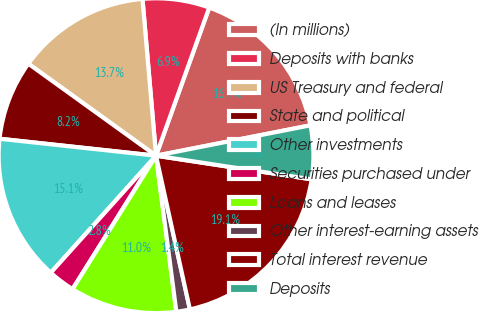<chart> <loc_0><loc_0><loc_500><loc_500><pie_chart><fcel>(In millions)<fcel>Deposits with banks<fcel>US Treasury and federal<fcel>State and political<fcel>Other investments<fcel>Securities purchased under<fcel>Loans and leases<fcel>Other interest-earning assets<fcel>Total interest revenue<fcel>Deposits<nl><fcel>16.42%<fcel>6.86%<fcel>13.69%<fcel>8.22%<fcel>15.06%<fcel>2.76%<fcel>10.96%<fcel>1.39%<fcel>19.15%<fcel>5.49%<nl></chart> 